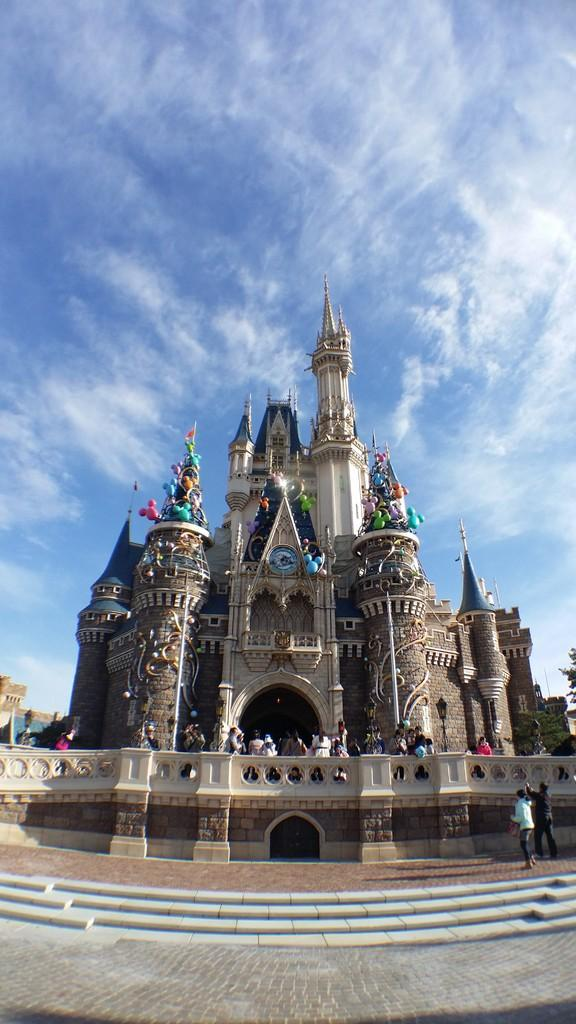What type of structure can be seen in the image? There is a castle in the image. What are the people in the image doing? People are walking in the image. What architectural feature is present in the image? There are stairs in the image. What is the color of the sky in the background? The sky is blue in the background. What can be seen in the sky? Clouds are visible in the sky. What type of reward is being handed out at the event in the image? There is no event or reward present in the image; it features a castle, people walking, stairs, and a blue sky with clouds. Can you tell me how many rabbits are hopping around in the image? There are no rabbits present in the image. 